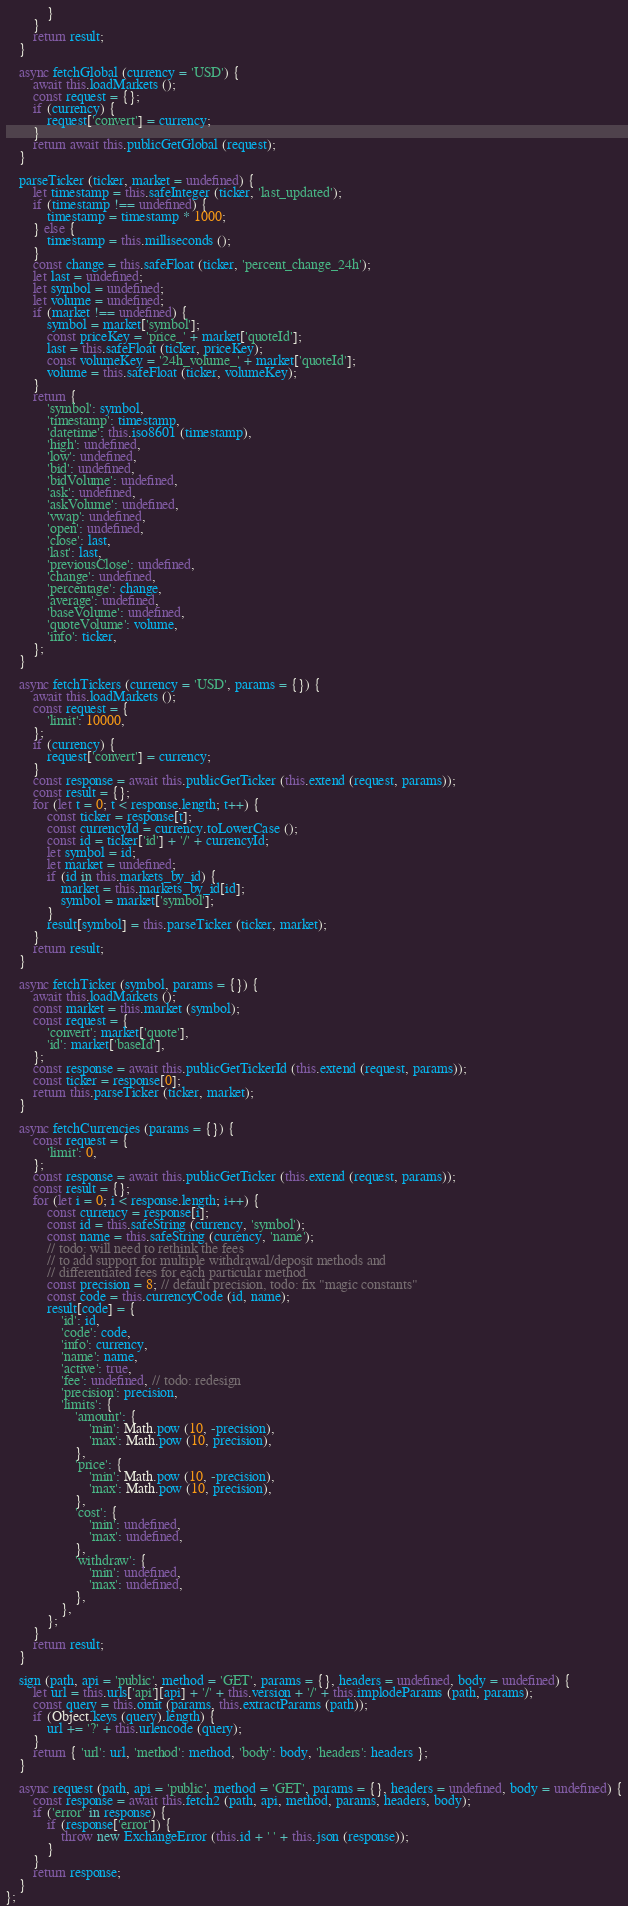<code> <loc_0><loc_0><loc_500><loc_500><_JavaScript_>            }
        }
        return result;
    }

    async fetchGlobal (currency = 'USD') {
        await this.loadMarkets ();
        const request = {};
        if (currency) {
            request['convert'] = currency;
        }
        return await this.publicGetGlobal (request);
    }

    parseTicker (ticker, market = undefined) {
        let timestamp = this.safeInteger (ticker, 'last_updated');
        if (timestamp !== undefined) {
            timestamp = timestamp * 1000;
        } else {
            timestamp = this.milliseconds ();
        }
        const change = this.safeFloat (ticker, 'percent_change_24h');
        let last = undefined;
        let symbol = undefined;
        let volume = undefined;
        if (market !== undefined) {
            symbol = market['symbol'];
            const priceKey = 'price_' + market['quoteId'];
            last = this.safeFloat (ticker, priceKey);
            const volumeKey = '24h_volume_' + market['quoteId'];
            volume = this.safeFloat (ticker, volumeKey);
        }
        return {
            'symbol': symbol,
            'timestamp': timestamp,
            'datetime': this.iso8601 (timestamp),
            'high': undefined,
            'low': undefined,
            'bid': undefined,
            'bidVolume': undefined,
            'ask': undefined,
            'askVolume': undefined,
            'vwap': undefined,
            'open': undefined,
            'close': last,
            'last': last,
            'previousClose': undefined,
            'change': undefined,
            'percentage': change,
            'average': undefined,
            'baseVolume': undefined,
            'quoteVolume': volume,
            'info': ticker,
        };
    }

    async fetchTickers (currency = 'USD', params = {}) {
        await this.loadMarkets ();
        const request = {
            'limit': 10000,
        };
        if (currency) {
            request['convert'] = currency;
        }
        const response = await this.publicGetTicker (this.extend (request, params));
        const result = {};
        for (let t = 0; t < response.length; t++) {
            const ticker = response[t];
            const currencyId = currency.toLowerCase ();
            const id = ticker['id'] + '/' + currencyId;
            let symbol = id;
            let market = undefined;
            if (id in this.markets_by_id) {
                market = this.markets_by_id[id];
                symbol = market['symbol'];
            }
            result[symbol] = this.parseTicker (ticker, market);
        }
        return result;
    }

    async fetchTicker (symbol, params = {}) {
        await this.loadMarkets ();
        const market = this.market (symbol);
        const request = {
            'convert': market['quote'],
            'id': market['baseId'],
        };
        const response = await this.publicGetTickerId (this.extend (request, params));
        const ticker = response[0];
        return this.parseTicker (ticker, market);
    }

    async fetchCurrencies (params = {}) {
        const request = {
            'limit': 0,
        };
        const response = await this.publicGetTicker (this.extend (request, params));
        const result = {};
        for (let i = 0; i < response.length; i++) {
            const currency = response[i];
            const id = this.safeString (currency, 'symbol');
            const name = this.safeString (currency, 'name');
            // todo: will need to rethink the fees
            // to add support for multiple withdrawal/deposit methods and
            // differentiated fees for each particular method
            const precision = 8; // default precision, todo: fix "magic constants"
            const code = this.currencyCode (id, name);
            result[code] = {
                'id': id,
                'code': code,
                'info': currency,
                'name': name,
                'active': true,
                'fee': undefined, // todo: redesign
                'precision': precision,
                'limits': {
                    'amount': {
                        'min': Math.pow (10, -precision),
                        'max': Math.pow (10, precision),
                    },
                    'price': {
                        'min': Math.pow (10, -precision),
                        'max': Math.pow (10, precision),
                    },
                    'cost': {
                        'min': undefined,
                        'max': undefined,
                    },
                    'withdraw': {
                        'min': undefined,
                        'max': undefined,
                    },
                },
            };
        }
        return result;
    }

    sign (path, api = 'public', method = 'GET', params = {}, headers = undefined, body = undefined) {
        let url = this.urls['api'][api] + '/' + this.version + '/' + this.implodeParams (path, params);
        const query = this.omit (params, this.extractParams (path));
        if (Object.keys (query).length) {
            url += '?' + this.urlencode (query);
        }
        return { 'url': url, 'method': method, 'body': body, 'headers': headers };
    }

    async request (path, api = 'public', method = 'GET', params = {}, headers = undefined, body = undefined) {
        const response = await this.fetch2 (path, api, method, params, headers, body);
        if ('error' in response) {
            if (response['error']) {
                throw new ExchangeError (this.id + ' ' + this.json (response));
            }
        }
        return response;
    }
};
</code> 